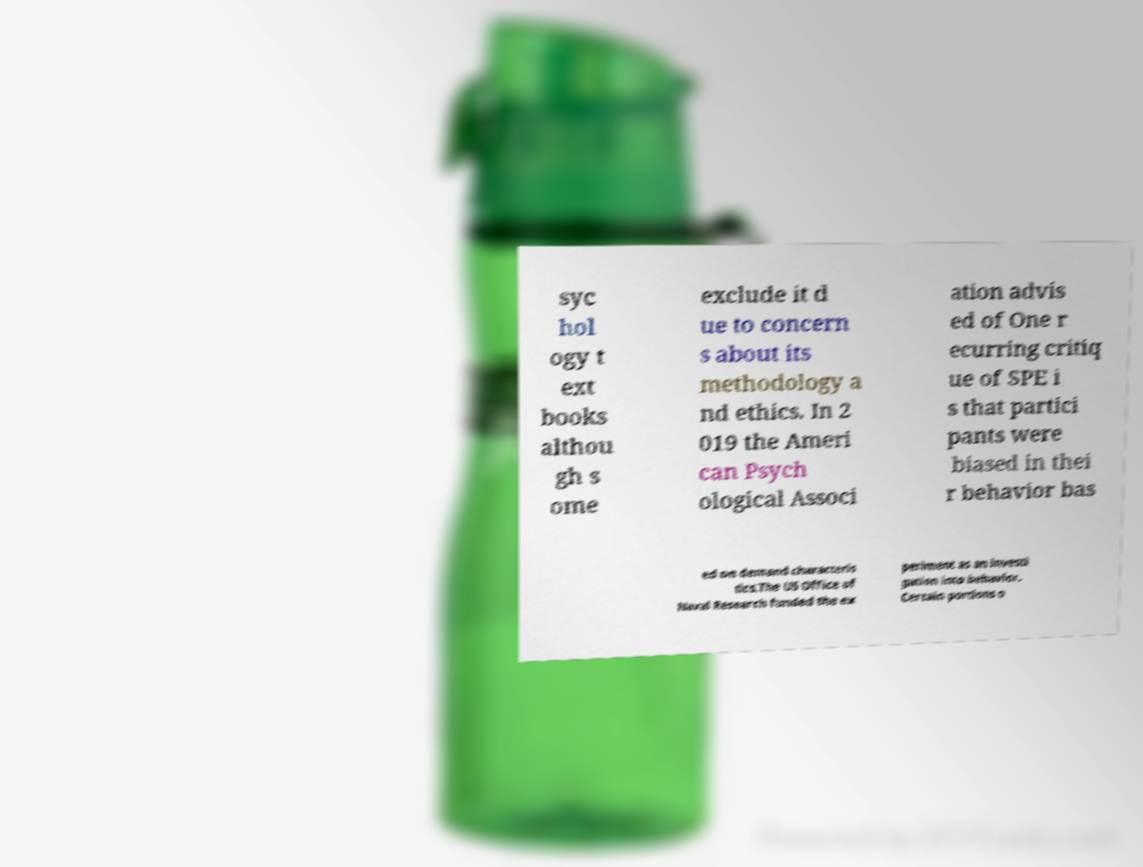What messages or text are displayed in this image? I need them in a readable, typed format. syc hol ogy t ext books althou gh s ome exclude it d ue to concern s about its methodology a nd ethics. In 2 019 the Ameri can Psych ological Associ ation advis ed of One r ecurring critiq ue of SPE i s that partici pants were biased in thei r behavior bas ed on demand characteris tics.The US Office of Naval Research funded the ex periment as an investi gation into behavior. Certain portions o 